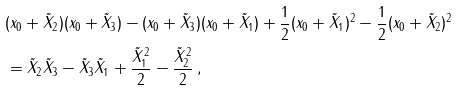<formula> <loc_0><loc_0><loc_500><loc_500>& ( x _ { 0 } + \tilde { X } _ { 2 } ) ( x _ { 0 } + \tilde { X } _ { 3 } ) - ( x _ { 0 } + \tilde { X } _ { 3 } ) ( x _ { 0 } + \tilde { X } _ { 1 } ) + \frac { 1 } { 2 } ( x _ { 0 } + \tilde { X } _ { 1 } ) ^ { 2 } - \frac { 1 } { 2 } ( x _ { 0 } + \tilde { X } _ { 2 } ) ^ { 2 } \\ & = \tilde { X } _ { 2 } \tilde { X } _ { 3 } - \tilde { X } _ { 3 } \tilde { X } _ { 1 } + \frac { \tilde { X } _ { 1 } ^ { 2 } } { 2 } - \frac { \tilde { X } _ { 2 } ^ { 2 } } { 2 } \, ,</formula> 